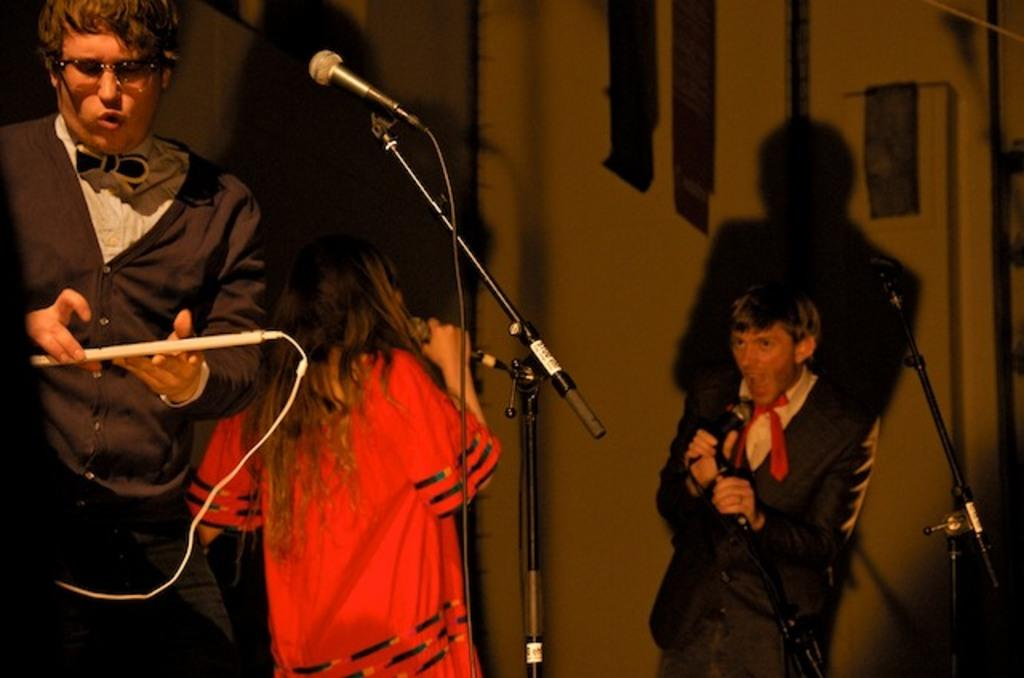What are the people in the image doing? There are people standing in the image, and a man and a woman are singing. How are the man and woman singing in the image? The man and woman are using microphones to sing. What is the man holding in the image? The man is holding an instrument in the image. Can you tell me how many frogs are singing along with the man and woman in the image? There are no frogs present in the image; it features a man and a woman singing with microphones. What type of toad can be seen playing the instrument in the image? There is no toad present in the image; it features a man holding an instrument. 